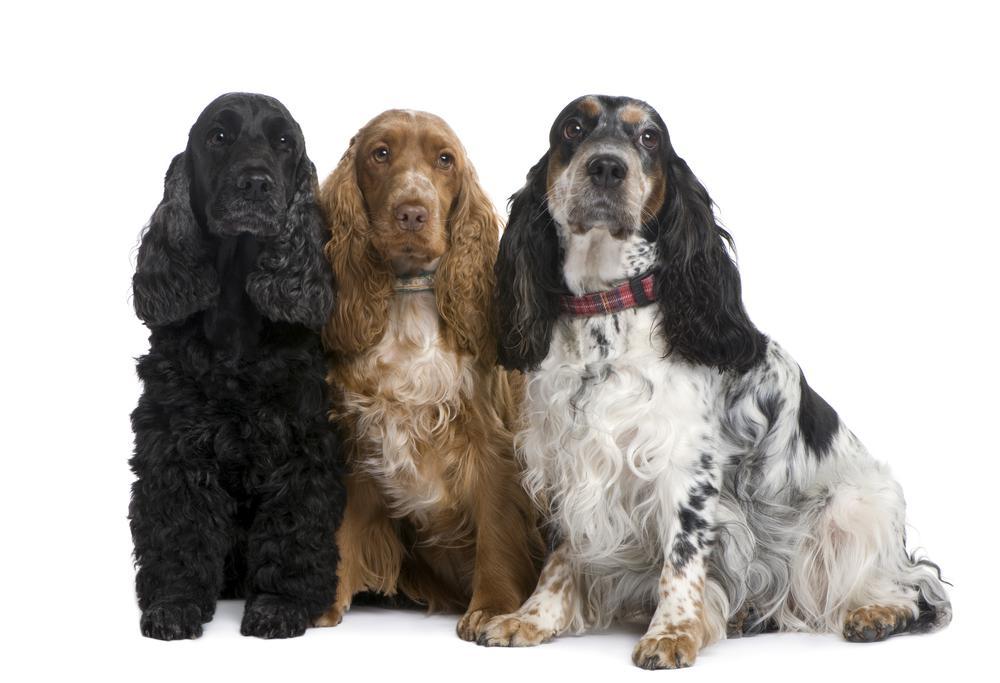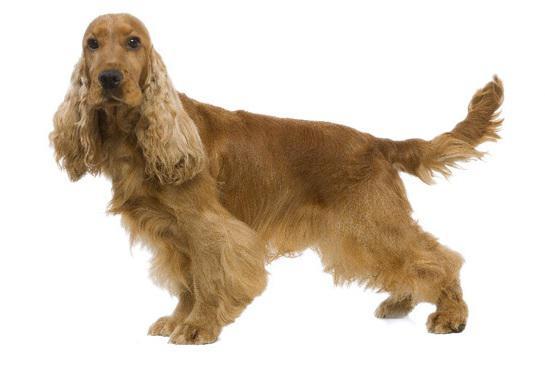The first image is the image on the left, the second image is the image on the right. Evaluate the accuracy of this statement regarding the images: "Each set of images contains exactly two animals.". Is it true? Answer yes or no. No. The first image is the image on the left, the second image is the image on the right. Considering the images on both sides, is "The image on the right contains a dark colored dog." valid? Answer yes or no. No. 